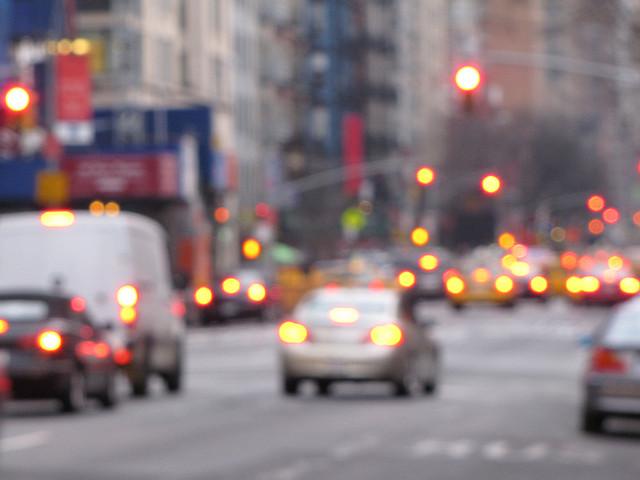Would you describe this picture is blurry?
Concise answer only. Yes. How many cars have their lights on?
Short answer required. 7. How many cars have their brake lights on?
Be succinct. 3. How many cars are in the picture?
Write a very short answer. 10. Is this a city scene?
Give a very brief answer. Yes. What is the color of the car?
Short answer required. Silver. How many lights are in the background?
Short answer required. 25. 